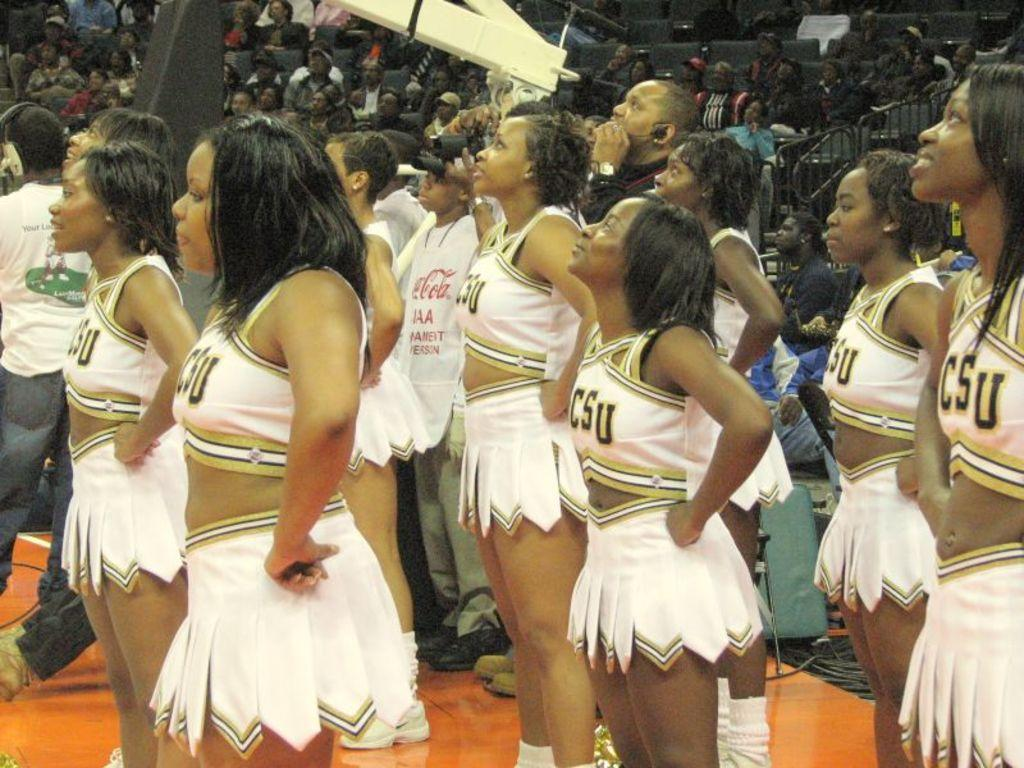Provide a one-sentence caption for the provided image. CSU cheerleaders wearing white outfits stand with their hands on their hips looking up. 